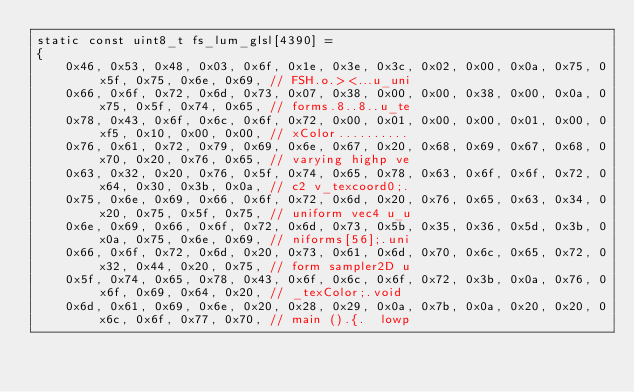Convert code to text. <code><loc_0><loc_0><loc_500><loc_500><_C_>static const uint8_t fs_lum_glsl[4390] =
{
	0x46, 0x53, 0x48, 0x03, 0x6f, 0x1e, 0x3e, 0x3c, 0x02, 0x00, 0x0a, 0x75, 0x5f, 0x75, 0x6e, 0x69, // FSH.o.><...u_uni
	0x66, 0x6f, 0x72, 0x6d, 0x73, 0x07, 0x38, 0x00, 0x00, 0x38, 0x00, 0x0a, 0x75, 0x5f, 0x74, 0x65, // forms.8..8..u_te
	0x78, 0x43, 0x6f, 0x6c, 0x6f, 0x72, 0x00, 0x01, 0x00, 0x00, 0x01, 0x00, 0xf5, 0x10, 0x00, 0x00, // xColor..........
	0x76, 0x61, 0x72, 0x79, 0x69, 0x6e, 0x67, 0x20, 0x68, 0x69, 0x67, 0x68, 0x70, 0x20, 0x76, 0x65, // varying highp ve
	0x63, 0x32, 0x20, 0x76, 0x5f, 0x74, 0x65, 0x78, 0x63, 0x6f, 0x6f, 0x72, 0x64, 0x30, 0x3b, 0x0a, // c2 v_texcoord0;.
	0x75, 0x6e, 0x69, 0x66, 0x6f, 0x72, 0x6d, 0x20, 0x76, 0x65, 0x63, 0x34, 0x20, 0x75, 0x5f, 0x75, // uniform vec4 u_u
	0x6e, 0x69, 0x66, 0x6f, 0x72, 0x6d, 0x73, 0x5b, 0x35, 0x36, 0x5d, 0x3b, 0x0a, 0x75, 0x6e, 0x69, // niforms[56];.uni
	0x66, 0x6f, 0x72, 0x6d, 0x20, 0x73, 0x61, 0x6d, 0x70, 0x6c, 0x65, 0x72, 0x32, 0x44, 0x20, 0x75, // form sampler2D u
	0x5f, 0x74, 0x65, 0x78, 0x43, 0x6f, 0x6c, 0x6f, 0x72, 0x3b, 0x0a, 0x76, 0x6f, 0x69, 0x64, 0x20, // _texColor;.void 
	0x6d, 0x61, 0x69, 0x6e, 0x20, 0x28, 0x29, 0x0a, 0x7b, 0x0a, 0x20, 0x20, 0x6c, 0x6f, 0x77, 0x70, // main ().{.  lowp</code> 